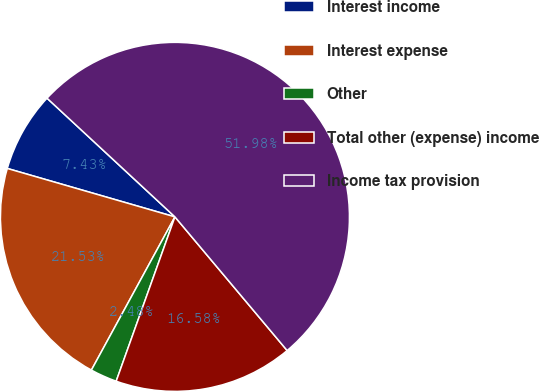Convert chart to OTSL. <chart><loc_0><loc_0><loc_500><loc_500><pie_chart><fcel>Interest income<fcel>Interest expense<fcel>Other<fcel>Total other (expense) income<fcel>Income tax provision<nl><fcel>7.43%<fcel>21.53%<fcel>2.48%<fcel>16.58%<fcel>51.98%<nl></chart> 